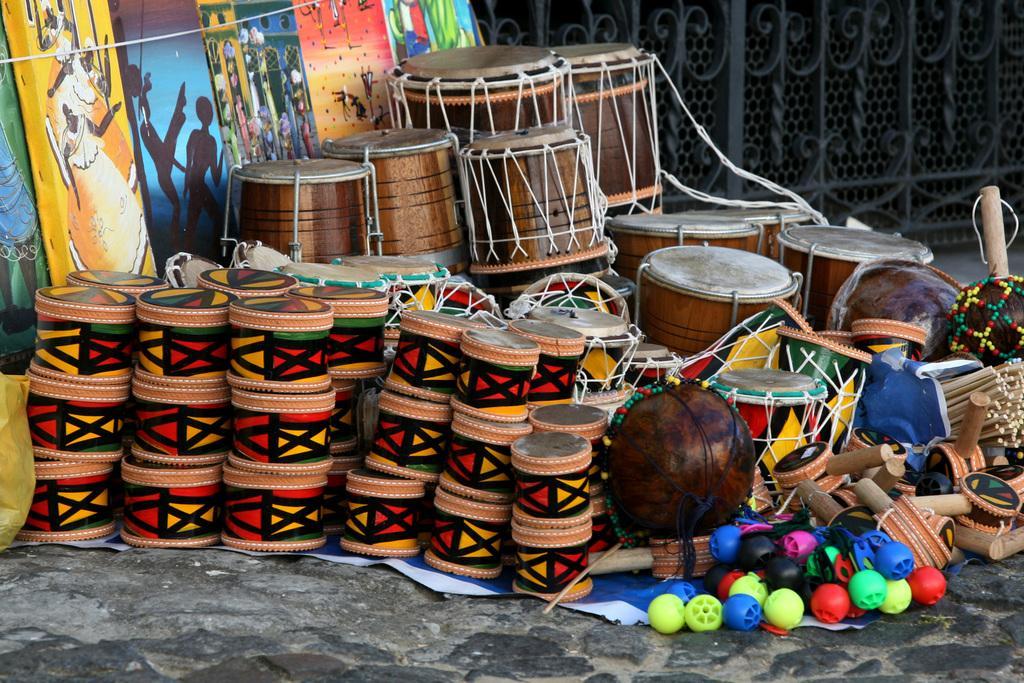Can you describe this image briefly? In this image there are drums and paintings, in the background there is a fencing. 